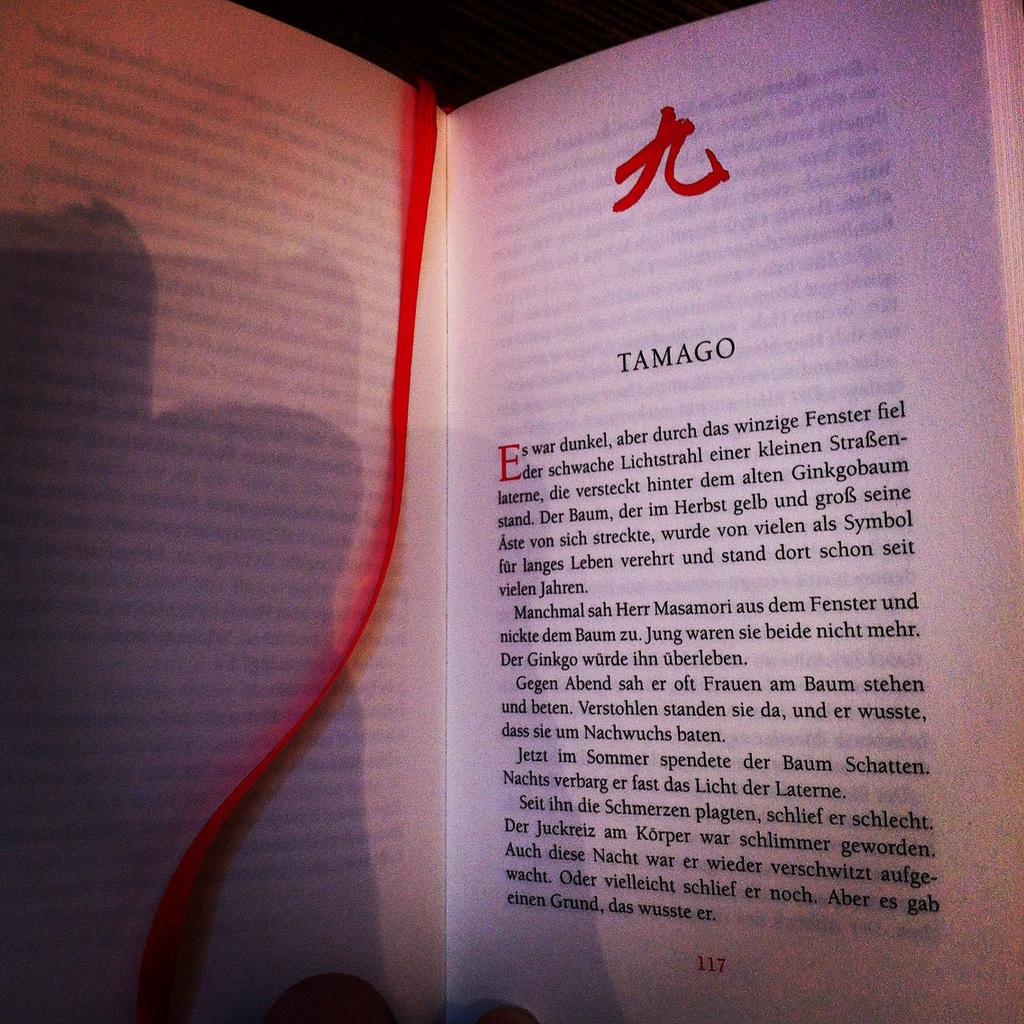What is the title of the chapter?
Your answer should be very brief. Tamago. What page number is this?
Keep it short and to the point. 117. 